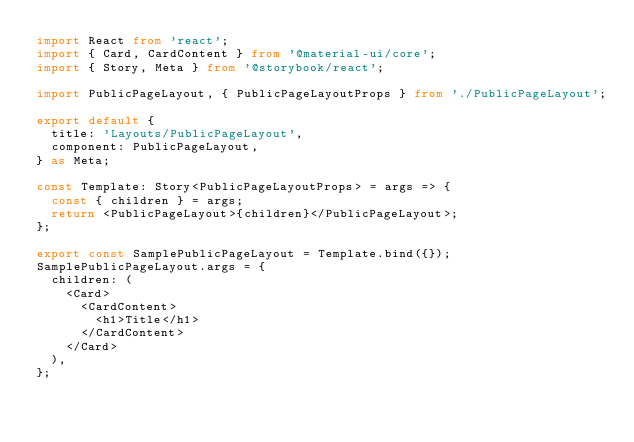<code> <loc_0><loc_0><loc_500><loc_500><_TypeScript_>import React from 'react';
import { Card, CardContent } from '@material-ui/core';
import { Story, Meta } from '@storybook/react';

import PublicPageLayout, { PublicPageLayoutProps } from './PublicPageLayout';

export default {
  title: 'Layouts/PublicPageLayout',
  component: PublicPageLayout,
} as Meta;

const Template: Story<PublicPageLayoutProps> = args => {
  const { children } = args;
  return <PublicPageLayout>{children}</PublicPageLayout>;
};

export const SamplePublicPageLayout = Template.bind({});
SamplePublicPageLayout.args = {
  children: (
    <Card>
      <CardContent>
        <h1>Title</h1>
      </CardContent>
    </Card>
  ),
};
</code> 